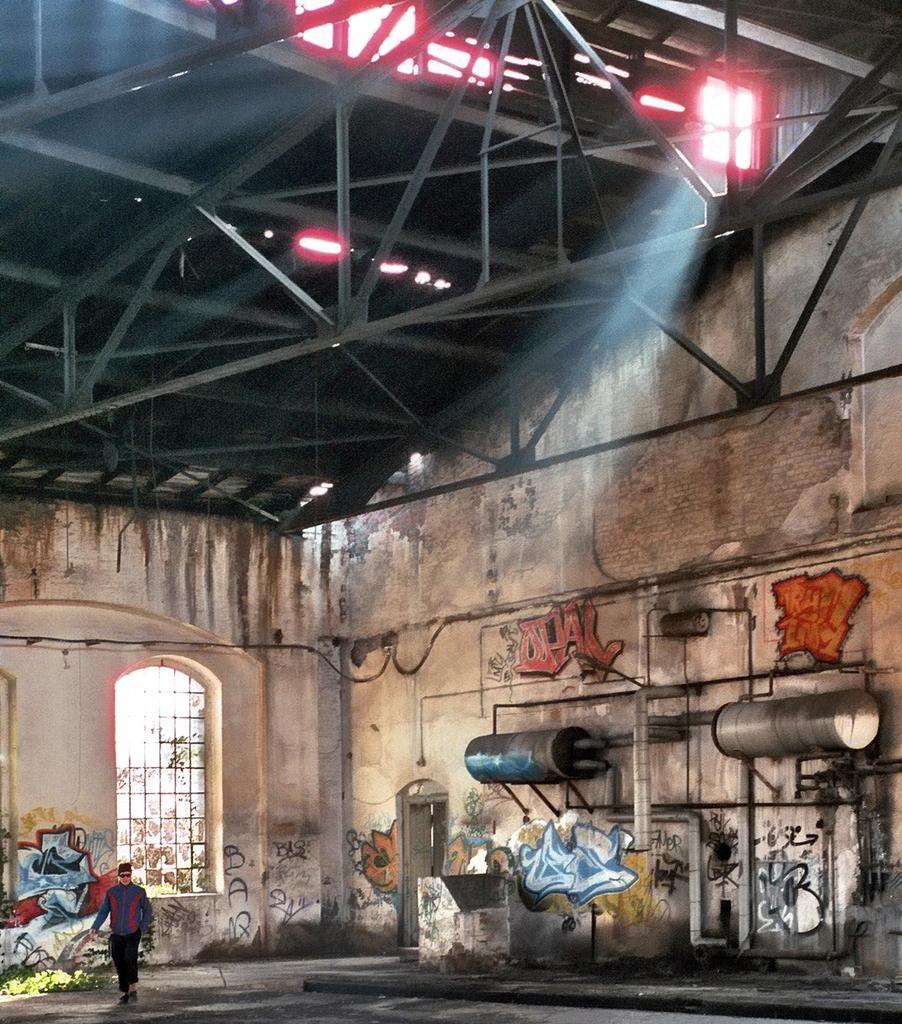What is the main subject of the image? There is a person in the image. What architectural feature can be seen in the image? There is a window in the image. What objects are cylindrical in shape in the image? There are cylinders in the image. What type of barrier is present in the image? Iron bars are present in the image. What type of infrastructure is visible in the image? Wires are visible in the image. What type of structure can be seen in the image? There is a wall in the image. How many pigs are visible in the image? There are no pigs present in the image. What is the reason for the person's presence in the image? The reason for the person's presence in the image cannot be determined from the provided facts. 